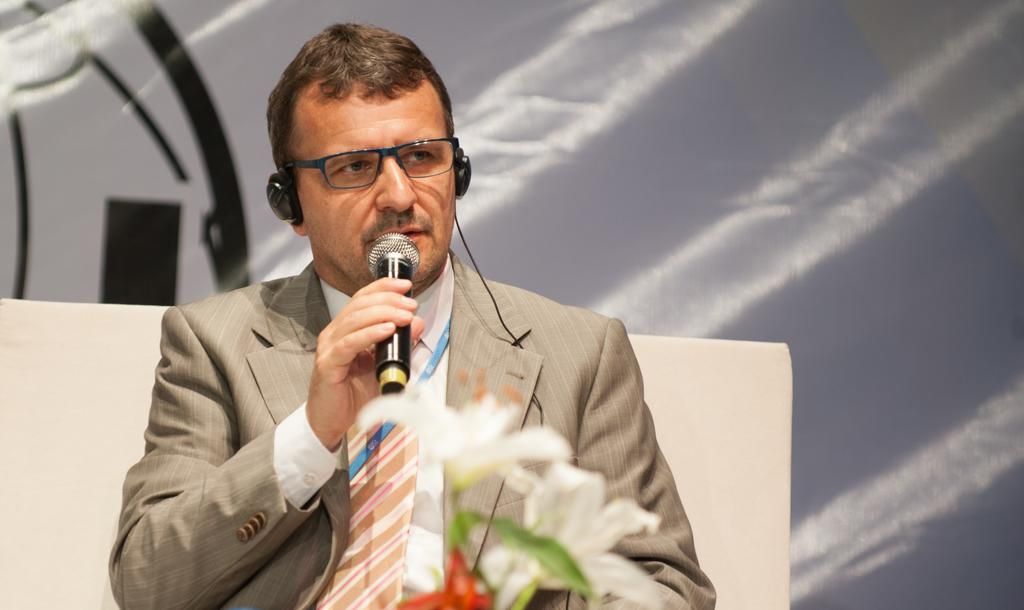What is the person in the image doing? The person is sitting on a chair and holding a microphone. What might the person be using the microphone for? The person might be using the microphone for recording or speaking. What is the person wearing in the image? The person is wearing headphones. What can be seen in front of the person? There is a flower in front of the person. What is visible in the background of the image? There is a sheet visible in the background. What type of soda is the person drinking in the image? There is no soda present in the image; the person is holding a microphone and wearing headphones. 